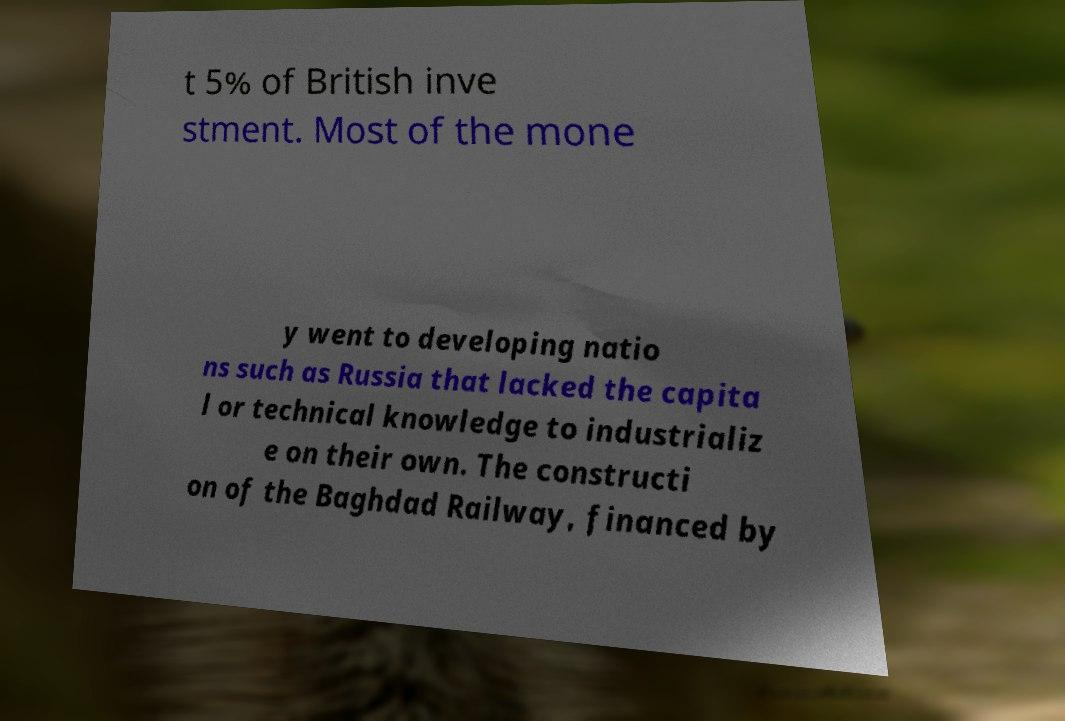What messages or text are displayed in this image? I need them in a readable, typed format. t 5% of British inve stment. Most of the mone y went to developing natio ns such as Russia that lacked the capita l or technical knowledge to industrializ e on their own. The constructi on of the Baghdad Railway, financed by 